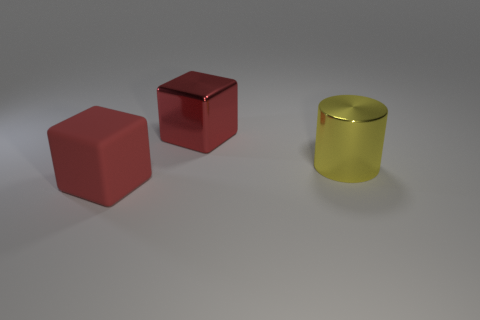Is the number of red cubes greater than the number of large objects?
Offer a very short reply. No. Is the size of the matte object the same as the red metal object?
Offer a very short reply. Yes. What number of things are small yellow balls or large objects?
Offer a terse response. 3. What shape is the red object that is left of the big red block behind the large red block that is in front of the large shiny block?
Your response must be concise. Cube. Does the large block behind the big red rubber object have the same material as the red thing that is in front of the yellow object?
Offer a terse response. No. There is another red object that is the same shape as the red metal thing; what material is it?
Make the answer very short. Rubber. Is there any other thing that is the same size as the red matte block?
Ensure brevity in your answer.  Yes. There is a red object that is behind the red matte thing; does it have the same shape as the large thing that is to the left of the large metallic block?
Offer a terse response. Yes. Are there fewer large blocks in front of the large red rubber block than matte things that are on the left side of the large yellow shiny thing?
Provide a short and direct response. Yes. What number of other objects are there of the same shape as the yellow object?
Your answer should be compact. 0. 